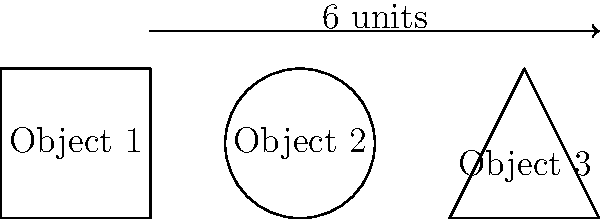In a PNG image, three non-contiguous objects are identified: a square with side length 2 units, a circle with radius 1 unit, and a right-angled triangle with base 2 units and height 2 units. Calculate the total perimeter of all objects in the image. Round your answer to two decimal places. To calculate the total perimeter, we need to sum the perimeters of all three objects:

1. Square perimeter:
   $P_{square} = 4s = 4 \times 2 = 8$ units

2. Circle perimeter:
   $P_{circle} = 2\pi r = 2\pi \times 1 = 2\pi$ units

3. Triangle perimeter:
   - Base = 2 units
   - Height = 2 units
   - Hypotenuse = $\sqrt{2^2 + 2^2} = \sqrt{8} = 2\sqrt{2}$ units
   $P_{triangle} = 2 + 2 + 2\sqrt{2}$ units

Total perimeter:
$$\begin{align*}
P_{total} &= P_{square} + P_{circle} + P_{triangle} \\
&= 8 + 2\pi + (2 + 2 + 2\sqrt{2}) \\
&= 12 + 2\pi + 2\sqrt{2} \\
&\approx 12 + 6.28 + 2.83 \\
&\approx 21.11 \text{ units}
\end{align*}$$

Rounding to two decimal places: 21.11 units
Answer: 21.11 units 